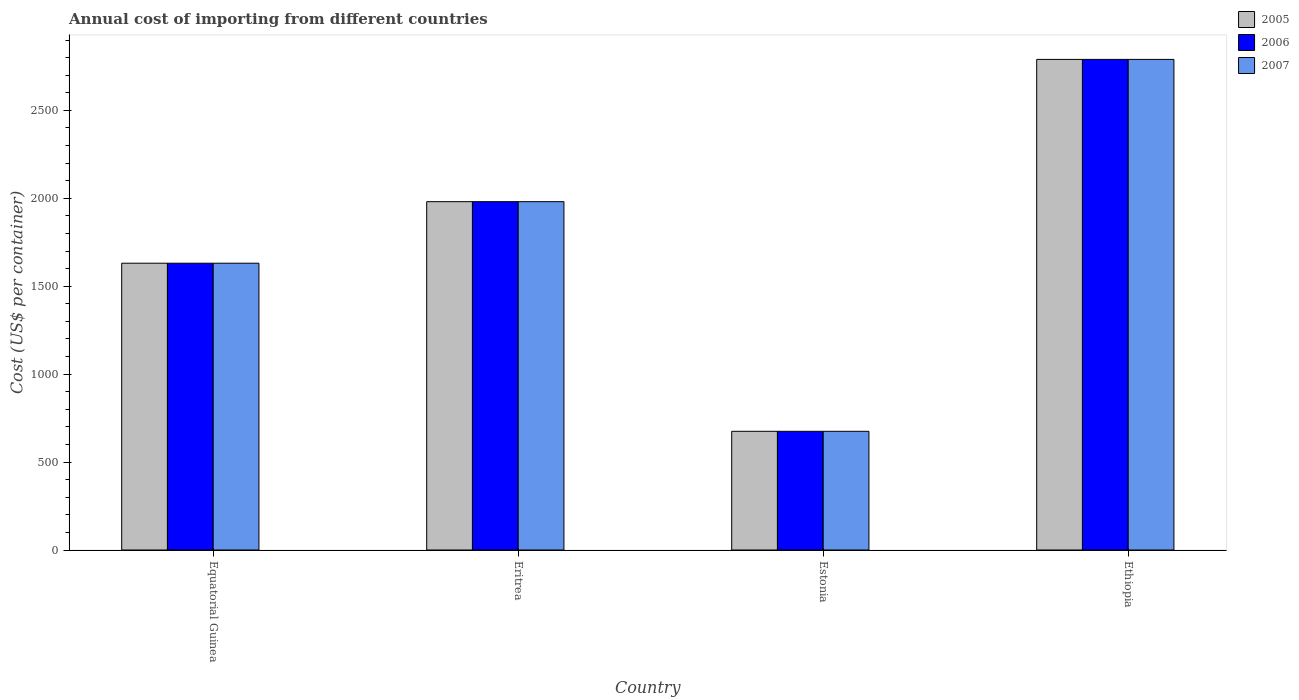How many different coloured bars are there?
Make the answer very short. 3. How many groups of bars are there?
Your answer should be compact. 4. Are the number of bars per tick equal to the number of legend labels?
Ensure brevity in your answer.  Yes. Are the number of bars on each tick of the X-axis equal?
Ensure brevity in your answer.  Yes. How many bars are there on the 2nd tick from the left?
Your response must be concise. 3. What is the label of the 3rd group of bars from the left?
Make the answer very short. Estonia. What is the total annual cost of importing in 2007 in Ethiopia?
Keep it short and to the point. 2790. Across all countries, what is the maximum total annual cost of importing in 2007?
Keep it short and to the point. 2790. Across all countries, what is the minimum total annual cost of importing in 2006?
Your answer should be compact. 675. In which country was the total annual cost of importing in 2007 maximum?
Offer a very short reply. Ethiopia. In which country was the total annual cost of importing in 2006 minimum?
Your answer should be compact. Estonia. What is the total total annual cost of importing in 2006 in the graph?
Keep it short and to the point. 7077. What is the difference between the total annual cost of importing in 2006 in Estonia and that in Ethiopia?
Offer a terse response. -2115. What is the difference between the total annual cost of importing in 2006 in Equatorial Guinea and the total annual cost of importing in 2007 in Ethiopia?
Keep it short and to the point. -1159. What is the average total annual cost of importing in 2007 per country?
Make the answer very short. 1769.25. What is the ratio of the total annual cost of importing in 2006 in Equatorial Guinea to that in Eritrea?
Ensure brevity in your answer.  0.82. Is the total annual cost of importing in 2005 in Estonia less than that in Ethiopia?
Offer a terse response. Yes. Is the difference between the total annual cost of importing in 2006 in Eritrea and Ethiopia greater than the difference between the total annual cost of importing in 2005 in Eritrea and Ethiopia?
Your answer should be compact. No. What is the difference between the highest and the second highest total annual cost of importing in 2006?
Give a very brief answer. -809. What is the difference between the highest and the lowest total annual cost of importing in 2005?
Offer a terse response. 2115. In how many countries, is the total annual cost of importing in 2006 greater than the average total annual cost of importing in 2006 taken over all countries?
Provide a succinct answer. 2. What does the 1st bar from the right in Equatorial Guinea represents?
Give a very brief answer. 2007. Is it the case that in every country, the sum of the total annual cost of importing in 2007 and total annual cost of importing in 2005 is greater than the total annual cost of importing in 2006?
Your answer should be compact. Yes. Are all the bars in the graph horizontal?
Your answer should be very brief. No. Does the graph contain grids?
Your response must be concise. No. Where does the legend appear in the graph?
Keep it short and to the point. Top right. What is the title of the graph?
Provide a short and direct response. Annual cost of importing from different countries. Does "1999" appear as one of the legend labels in the graph?
Your response must be concise. No. What is the label or title of the X-axis?
Provide a short and direct response. Country. What is the label or title of the Y-axis?
Keep it short and to the point. Cost (US$ per container). What is the Cost (US$ per container) in 2005 in Equatorial Guinea?
Your answer should be compact. 1631. What is the Cost (US$ per container) in 2006 in Equatorial Guinea?
Offer a terse response. 1631. What is the Cost (US$ per container) in 2007 in Equatorial Guinea?
Keep it short and to the point. 1631. What is the Cost (US$ per container) in 2005 in Eritrea?
Provide a short and direct response. 1981. What is the Cost (US$ per container) of 2006 in Eritrea?
Ensure brevity in your answer.  1981. What is the Cost (US$ per container) in 2007 in Eritrea?
Provide a succinct answer. 1981. What is the Cost (US$ per container) of 2005 in Estonia?
Give a very brief answer. 675. What is the Cost (US$ per container) in 2006 in Estonia?
Ensure brevity in your answer.  675. What is the Cost (US$ per container) of 2007 in Estonia?
Your response must be concise. 675. What is the Cost (US$ per container) in 2005 in Ethiopia?
Provide a succinct answer. 2790. What is the Cost (US$ per container) of 2006 in Ethiopia?
Offer a very short reply. 2790. What is the Cost (US$ per container) in 2007 in Ethiopia?
Ensure brevity in your answer.  2790. Across all countries, what is the maximum Cost (US$ per container) in 2005?
Offer a terse response. 2790. Across all countries, what is the maximum Cost (US$ per container) of 2006?
Ensure brevity in your answer.  2790. Across all countries, what is the maximum Cost (US$ per container) of 2007?
Your answer should be very brief. 2790. Across all countries, what is the minimum Cost (US$ per container) of 2005?
Keep it short and to the point. 675. Across all countries, what is the minimum Cost (US$ per container) in 2006?
Provide a succinct answer. 675. Across all countries, what is the minimum Cost (US$ per container) in 2007?
Your answer should be very brief. 675. What is the total Cost (US$ per container) of 2005 in the graph?
Ensure brevity in your answer.  7077. What is the total Cost (US$ per container) in 2006 in the graph?
Give a very brief answer. 7077. What is the total Cost (US$ per container) of 2007 in the graph?
Your answer should be compact. 7077. What is the difference between the Cost (US$ per container) in 2005 in Equatorial Guinea and that in Eritrea?
Make the answer very short. -350. What is the difference between the Cost (US$ per container) in 2006 in Equatorial Guinea and that in Eritrea?
Ensure brevity in your answer.  -350. What is the difference between the Cost (US$ per container) of 2007 in Equatorial Guinea and that in Eritrea?
Offer a very short reply. -350. What is the difference between the Cost (US$ per container) of 2005 in Equatorial Guinea and that in Estonia?
Keep it short and to the point. 956. What is the difference between the Cost (US$ per container) of 2006 in Equatorial Guinea and that in Estonia?
Make the answer very short. 956. What is the difference between the Cost (US$ per container) in 2007 in Equatorial Guinea and that in Estonia?
Your response must be concise. 956. What is the difference between the Cost (US$ per container) in 2005 in Equatorial Guinea and that in Ethiopia?
Your response must be concise. -1159. What is the difference between the Cost (US$ per container) of 2006 in Equatorial Guinea and that in Ethiopia?
Give a very brief answer. -1159. What is the difference between the Cost (US$ per container) of 2007 in Equatorial Guinea and that in Ethiopia?
Offer a very short reply. -1159. What is the difference between the Cost (US$ per container) in 2005 in Eritrea and that in Estonia?
Keep it short and to the point. 1306. What is the difference between the Cost (US$ per container) of 2006 in Eritrea and that in Estonia?
Give a very brief answer. 1306. What is the difference between the Cost (US$ per container) of 2007 in Eritrea and that in Estonia?
Give a very brief answer. 1306. What is the difference between the Cost (US$ per container) in 2005 in Eritrea and that in Ethiopia?
Your answer should be compact. -809. What is the difference between the Cost (US$ per container) in 2006 in Eritrea and that in Ethiopia?
Provide a short and direct response. -809. What is the difference between the Cost (US$ per container) of 2007 in Eritrea and that in Ethiopia?
Provide a short and direct response. -809. What is the difference between the Cost (US$ per container) of 2005 in Estonia and that in Ethiopia?
Ensure brevity in your answer.  -2115. What is the difference between the Cost (US$ per container) of 2006 in Estonia and that in Ethiopia?
Provide a short and direct response. -2115. What is the difference between the Cost (US$ per container) of 2007 in Estonia and that in Ethiopia?
Your response must be concise. -2115. What is the difference between the Cost (US$ per container) in 2005 in Equatorial Guinea and the Cost (US$ per container) in 2006 in Eritrea?
Your answer should be compact. -350. What is the difference between the Cost (US$ per container) of 2005 in Equatorial Guinea and the Cost (US$ per container) of 2007 in Eritrea?
Offer a very short reply. -350. What is the difference between the Cost (US$ per container) of 2006 in Equatorial Guinea and the Cost (US$ per container) of 2007 in Eritrea?
Offer a terse response. -350. What is the difference between the Cost (US$ per container) of 2005 in Equatorial Guinea and the Cost (US$ per container) of 2006 in Estonia?
Your answer should be very brief. 956. What is the difference between the Cost (US$ per container) of 2005 in Equatorial Guinea and the Cost (US$ per container) of 2007 in Estonia?
Give a very brief answer. 956. What is the difference between the Cost (US$ per container) of 2006 in Equatorial Guinea and the Cost (US$ per container) of 2007 in Estonia?
Offer a terse response. 956. What is the difference between the Cost (US$ per container) of 2005 in Equatorial Guinea and the Cost (US$ per container) of 2006 in Ethiopia?
Offer a terse response. -1159. What is the difference between the Cost (US$ per container) of 2005 in Equatorial Guinea and the Cost (US$ per container) of 2007 in Ethiopia?
Keep it short and to the point. -1159. What is the difference between the Cost (US$ per container) of 2006 in Equatorial Guinea and the Cost (US$ per container) of 2007 in Ethiopia?
Your answer should be compact. -1159. What is the difference between the Cost (US$ per container) of 2005 in Eritrea and the Cost (US$ per container) of 2006 in Estonia?
Offer a very short reply. 1306. What is the difference between the Cost (US$ per container) of 2005 in Eritrea and the Cost (US$ per container) of 2007 in Estonia?
Offer a terse response. 1306. What is the difference between the Cost (US$ per container) of 2006 in Eritrea and the Cost (US$ per container) of 2007 in Estonia?
Provide a succinct answer. 1306. What is the difference between the Cost (US$ per container) in 2005 in Eritrea and the Cost (US$ per container) in 2006 in Ethiopia?
Your answer should be very brief. -809. What is the difference between the Cost (US$ per container) of 2005 in Eritrea and the Cost (US$ per container) of 2007 in Ethiopia?
Give a very brief answer. -809. What is the difference between the Cost (US$ per container) in 2006 in Eritrea and the Cost (US$ per container) in 2007 in Ethiopia?
Make the answer very short. -809. What is the difference between the Cost (US$ per container) in 2005 in Estonia and the Cost (US$ per container) in 2006 in Ethiopia?
Provide a short and direct response. -2115. What is the difference between the Cost (US$ per container) in 2005 in Estonia and the Cost (US$ per container) in 2007 in Ethiopia?
Your response must be concise. -2115. What is the difference between the Cost (US$ per container) of 2006 in Estonia and the Cost (US$ per container) of 2007 in Ethiopia?
Give a very brief answer. -2115. What is the average Cost (US$ per container) of 2005 per country?
Offer a very short reply. 1769.25. What is the average Cost (US$ per container) of 2006 per country?
Ensure brevity in your answer.  1769.25. What is the average Cost (US$ per container) of 2007 per country?
Offer a very short reply. 1769.25. What is the difference between the Cost (US$ per container) in 2006 and Cost (US$ per container) in 2007 in Equatorial Guinea?
Make the answer very short. 0. What is the difference between the Cost (US$ per container) in 2005 and Cost (US$ per container) in 2006 in Eritrea?
Provide a succinct answer. 0. What is the difference between the Cost (US$ per container) in 2005 and Cost (US$ per container) in 2007 in Eritrea?
Your response must be concise. 0. What is the difference between the Cost (US$ per container) in 2005 and Cost (US$ per container) in 2007 in Ethiopia?
Make the answer very short. 0. What is the ratio of the Cost (US$ per container) in 2005 in Equatorial Guinea to that in Eritrea?
Provide a succinct answer. 0.82. What is the ratio of the Cost (US$ per container) of 2006 in Equatorial Guinea to that in Eritrea?
Offer a terse response. 0.82. What is the ratio of the Cost (US$ per container) of 2007 in Equatorial Guinea to that in Eritrea?
Your answer should be very brief. 0.82. What is the ratio of the Cost (US$ per container) of 2005 in Equatorial Guinea to that in Estonia?
Keep it short and to the point. 2.42. What is the ratio of the Cost (US$ per container) of 2006 in Equatorial Guinea to that in Estonia?
Offer a terse response. 2.42. What is the ratio of the Cost (US$ per container) of 2007 in Equatorial Guinea to that in Estonia?
Your response must be concise. 2.42. What is the ratio of the Cost (US$ per container) of 2005 in Equatorial Guinea to that in Ethiopia?
Give a very brief answer. 0.58. What is the ratio of the Cost (US$ per container) of 2006 in Equatorial Guinea to that in Ethiopia?
Your answer should be compact. 0.58. What is the ratio of the Cost (US$ per container) of 2007 in Equatorial Guinea to that in Ethiopia?
Keep it short and to the point. 0.58. What is the ratio of the Cost (US$ per container) in 2005 in Eritrea to that in Estonia?
Your response must be concise. 2.93. What is the ratio of the Cost (US$ per container) of 2006 in Eritrea to that in Estonia?
Provide a succinct answer. 2.93. What is the ratio of the Cost (US$ per container) of 2007 in Eritrea to that in Estonia?
Ensure brevity in your answer.  2.93. What is the ratio of the Cost (US$ per container) of 2005 in Eritrea to that in Ethiopia?
Give a very brief answer. 0.71. What is the ratio of the Cost (US$ per container) in 2006 in Eritrea to that in Ethiopia?
Provide a short and direct response. 0.71. What is the ratio of the Cost (US$ per container) in 2007 in Eritrea to that in Ethiopia?
Offer a terse response. 0.71. What is the ratio of the Cost (US$ per container) of 2005 in Estonia to that in Ethiopia?
Provide a short and direct response. 0.24. What is the ratio of the Cost (US$ per container) in 2006 in Estonia to that in Ethiopia?
Your answer should be compact. 0.24. What is the ratio of the Cost (US$ per container) in 2007 in Estonia to that in Ethiopia?
Your answer should be compact. 0.24. What is the difference between the highest and the second highest Cost (US$ per container) in 2005?
Give a very brief answer. 809. What is the difference between the highest and the second highest Cost (US$ per container) of 2006?
Give a very brief answer. 809. What is the difference between the highest and the second highest Cost (US$ per container) in 2007?
Make the answer very short. 809. What is the difference between the highest and the lowest Cost (US$ per container) of 2005?
Your answer should be compact. 2115. What is the difference between the highest and the lowest Cost (US$ per container) in 2006?
Provide a short and direct response. 2115. What is the difference between the highest and the lowest Cost (US$ per container) of 2007?
Offer a terse response. 2115. 